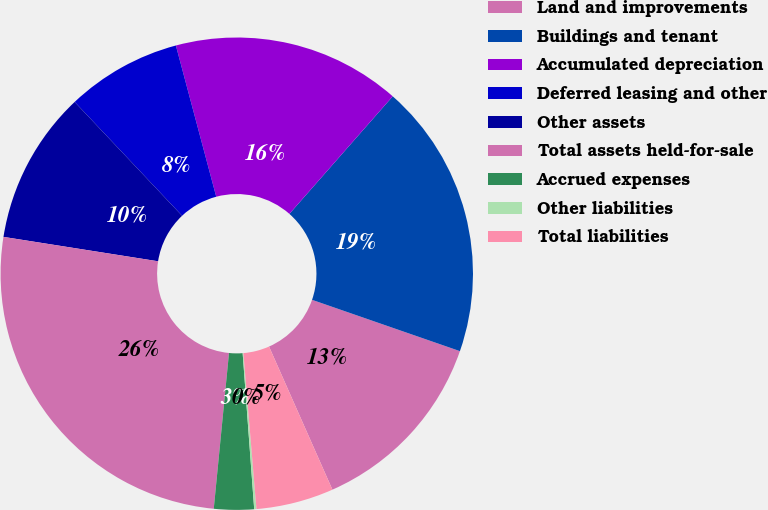<chart> <loc_0><loc_0><loc_500><loc_500><pie_chart><fcel>Land and improvements<fcel>Buildings and tenant<fcel>Accumulated depreciation<fcel>Deferred leasing and other<fcel>Other assets<fcel>Total assets held-for-sale<fcel>Accrued expenses<fcel>Other liabilities<fcel>Total liabilities<nl><fcel>13.05%<fcel>18.84%<fcel>15.63%<fcel>7.89%<fcel>10.47%<fcel>25.94%<fcel>2.73%<fcel>0.15%<fcel>5.31%<nl></chart> 